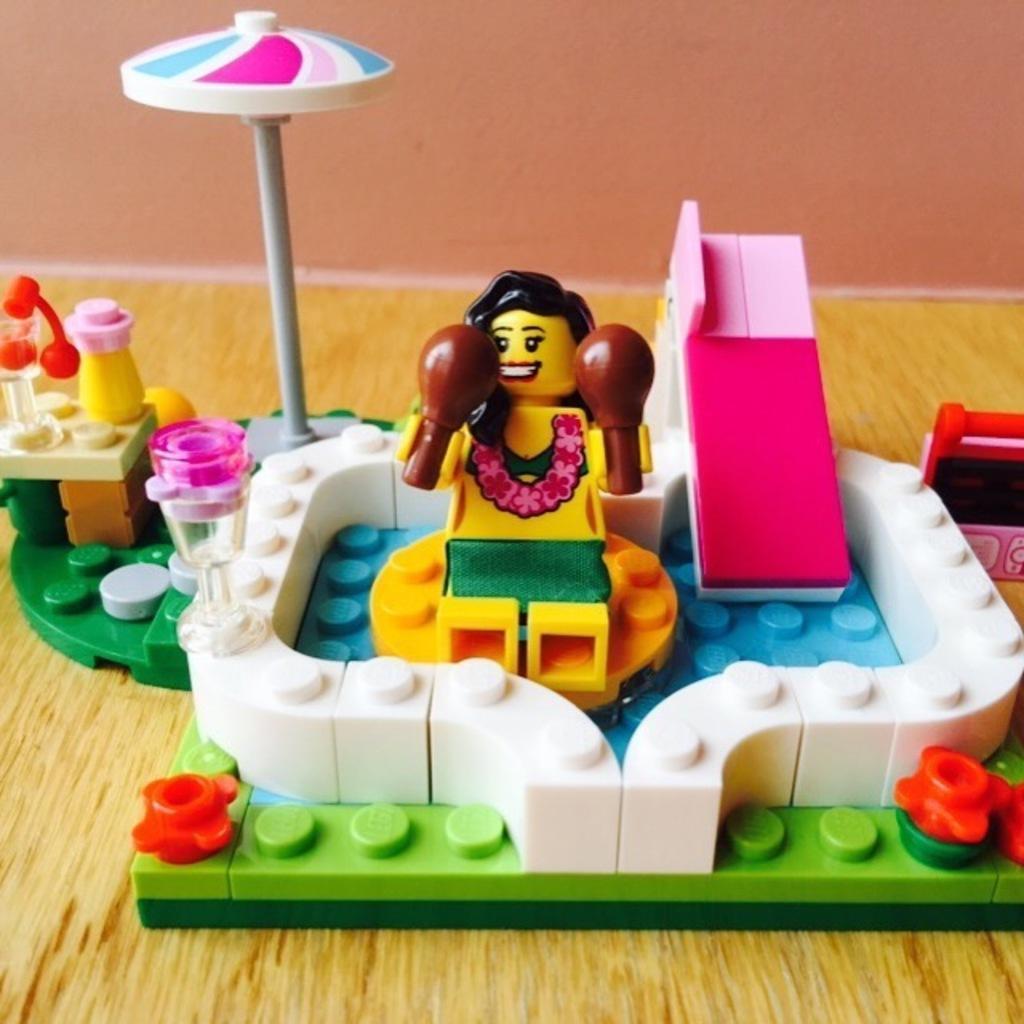Could you give a brief overview of what you see in this image? in this picture i can see a toys on the floor 